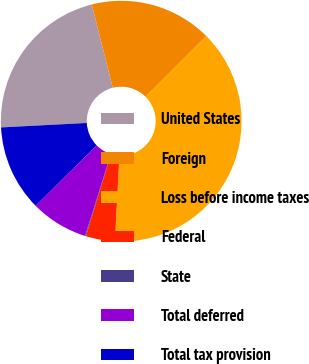Convert chart to OTSL. <chart><loc_0><loc_0><loc_500><loc_500><pie_chart><fcel>United States<fcel>Foreign<fcel>Loss before income taxes<fcel>Federal<fcel>State<fcel>Total deferred<fcel>Total tax provision<nl><fcel>21.9%<fcel>16.43%<fcel>38.33%<fcel>3.92%<fcel>0.1%<fcel>7.75%<fcel>11.57%<nl></chart> 